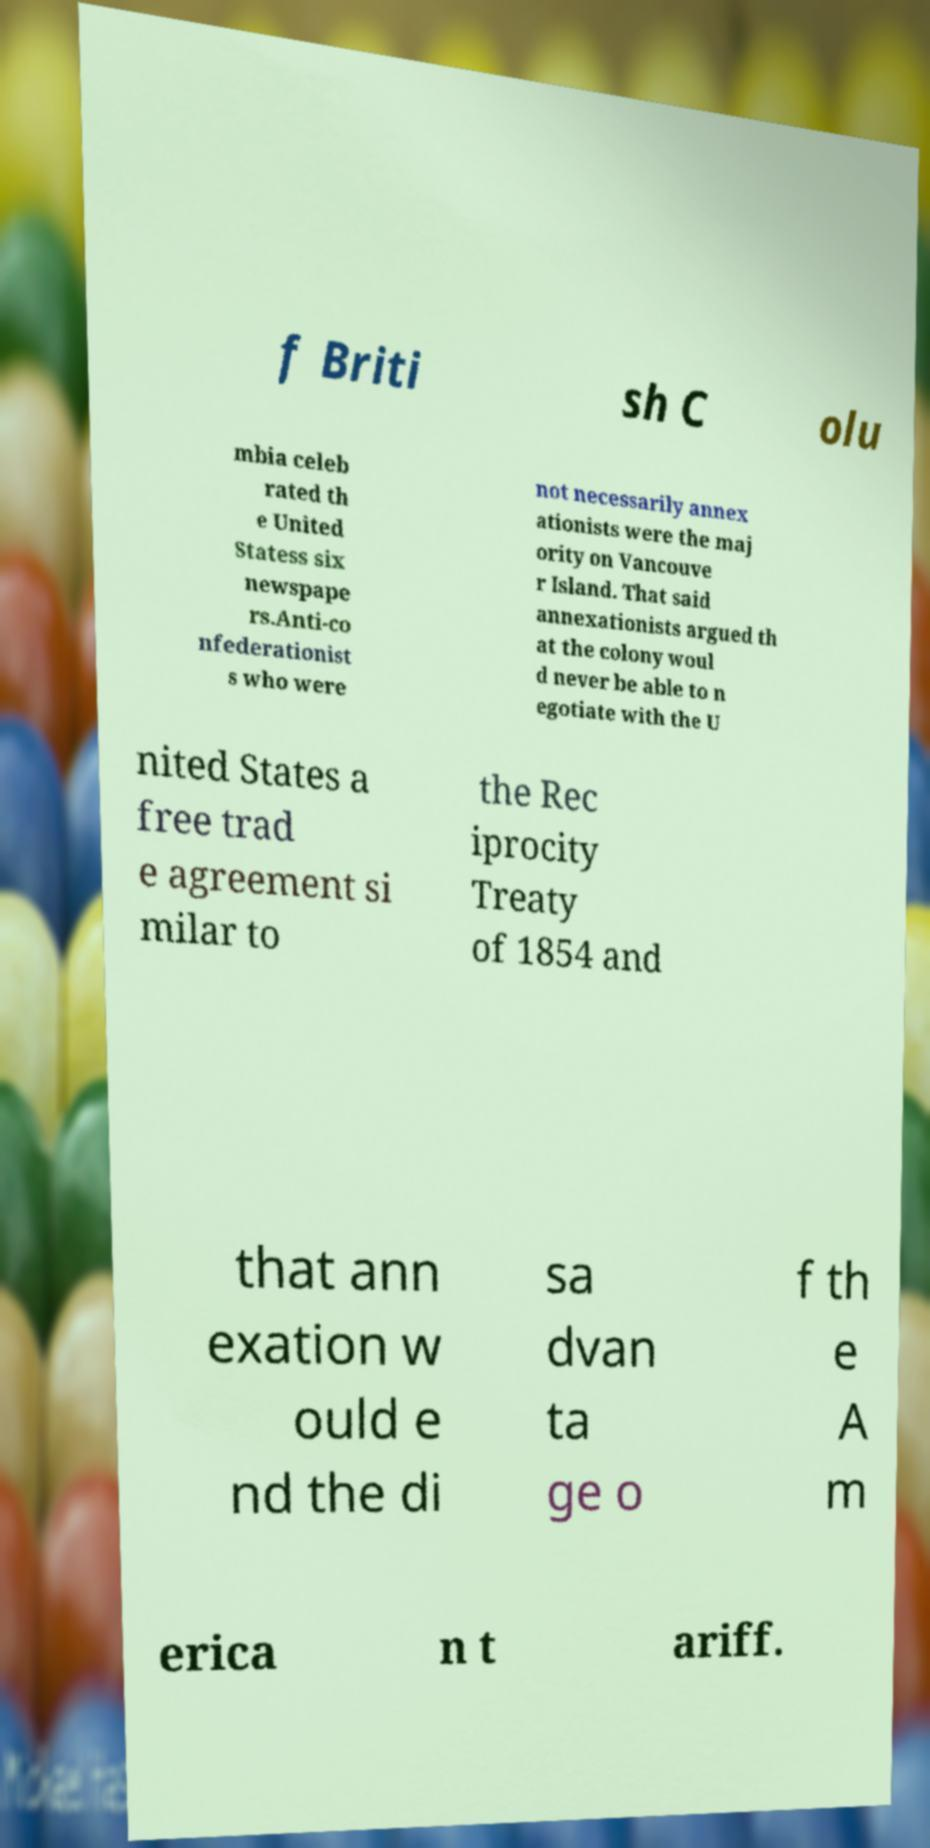I need the written content from this picture converted into text. Can you do that? f Briti sh C olu mbia celeb rated th e United Statess six newspape rs.Anti-co nfederationist s who were not necessarily annex ationists were the maj ority on Vancouve r Island. That said annexationists argued th at the colony woul d never be able to n egotiate with the U nited States a free trad e agreement si milar to the Rec iprocity Treaty of 1854 and that ann exation w ould e nd the di sa dvan ta ge o f th e A m erica n t ariff. 